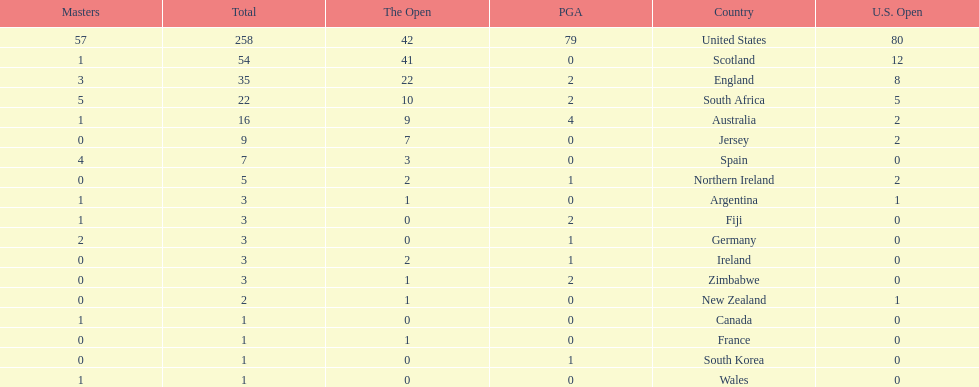Combined, how many winning golfers does england and wales have in the masters? 4. Would you be able to parse every entry in this table? {'header': ['Masters', 'Total', 'The Open', 'PGA', 'Country', 'U.S. Open'], 'rows': [['57', '258', '42', '79', 'United States', '80'], ['1', '54', '41', '0', 'Scotland', '12'], ['3', '35', '22', '2', 'England', '8'], ['5', '22', '10', '2', 'South Africa', '5'], ['1', '16', '9', '4', 'Australia', '2'], ['0', '9', '7', '0', 'Jersey', '2'], ['4', '7', '3', '0', 'Spain', '0'], ['0', '5', '2', '1', 'Northern Ireland', '2'], ['1', '3', '1', '0', 'Argentina', '1'], ['1', '3', '0', '2', 'Fiji', '0'], ['2', '3', '0', '1', 'Germany', '0'], ['0', '3', '2', '1', 'Ireland', '0'], ['0', '3', '1', '2', 'Zimbabwe', '0'], ['0', '2', '1', '0', 'New Zealand', '1'], ['1', '1', '0', '0', 'Canada', '0'], ['0', '1', '1', '0', 'France', '0'], ['0', '1', '0', '1', 'South Korea', '0'], ['1', '1', '0', '0', 'Wales', '0']]} 